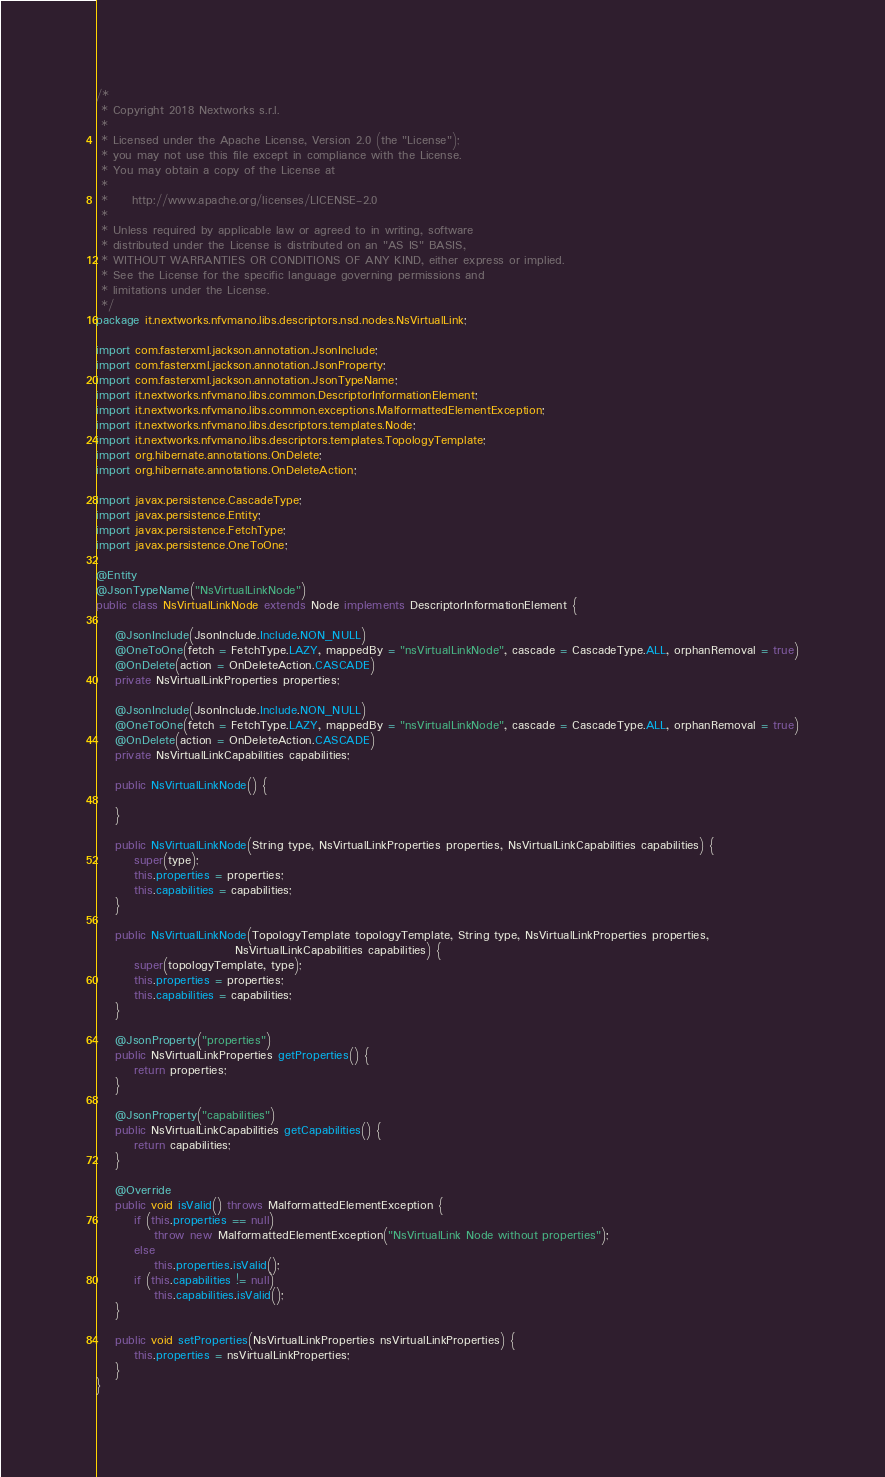<code> <loc_0><loc_0><loc_500><loc_500><_Java_>/*
 * Copyright 2018 Nextworks s.r.l.
 *
 * Licensed under the Apache License, Version 2.0 (the "License");
 * you may not use this file except in compliance with the License.
 * You may obtain a copy of the License at
 *
 *     http://www.apache.org/licenses/LICENSE-2.0
 *
 * Unless required by applicable law or agreed to in writing, software
 * distributed under the License is distributed on an "AS IS" BASIS,
 * WITHOUT WARRANTIES OR CONDITIONS OF ANY KIND, either express or implied.
 * See the License for the specific language governing permissions and
 * limitations under the License.
 */
package it.nextworks.nfvmano.libs.descriptors.nsd.nodes.NsVirtualLink;

import com.fasterxml.jackson.annotation.JsonInclude;
import com.fasterxml.jackson.annotation.JsonProperty;
import com.fasterxml.jackson.annotation.JsonTypeName;
import it.nextworks.nfvmano.libs.common.DescriptorInformationElement;
import it.nextworks.nfvmano.libs.common.exceptions.MalformattedElementException;
import it.nextworks.nfvmano.libs.descriptors.templates.Node;
import it.nextworks.nfvmano.libs.descriptors.templates.TopologyTemplate;
import org.hibernate.annotations.OnDelete;
import org.hibernate.annotations.OnDeleteAction;

import javax.persistence.CascadeType;
import javax.persistence.Entity;
import javax.persistence.FetchType;
import javax.persistence.OneToOne;

@Entity
@JsonTypeName("NsVirtualLinkNode")
public class NsVirtualLinkNode extends Node implements DescriptorInformationElement {

    @JsonInclude(JsonInclude.Include.NON_NULL)
    @OneToOne(fetch = FetchType.LAZY, mappedBy = "nsVirtualLinkNode", cascade = CascadeType.ALL, orphanRemoval = true)
    @OnDelete(action = OnDeleteAction.CASCADE)
    private NsVirtualLinkProperties properties;

    @JsonInclude(JsonInclude.Include.NON_NULL)
    @OneToOne(fetch = FetchType.LAZY, mappedBy = "nsVirtualLinkNode", cascade = CascadeType.ALL, orphanRemoval = true)
    @OnDelete(action = OnDeleteAction.CASCADE)
    private NsVirtualLinkCapabilities capabilities;

    public NsVirtualLinkNode() {

    }

    public NsVirtualLinkNode(String type, NsVirtualLinkProperties properties, NsVirtualLinkCapabilities capabilities) {
        super(type);
        this.properties = properties;
        this.capabilities = capabilities;
    }

    public NsVirtualLinkNode(TopologyTemplate topologyTemplate, String type, NsVirtualLinkProperties properties,
                             NsVirtualLinkCapabilities capabilities) {
        super(topologyTemplate, type);
        this.properties = properties;
        this.capabilities = capabilities;
    }

    @JsonProperty("properties")
    public NsVirtualLinkProperties getProperties() {
        return properties;
    }

    @JsonProperty("capabilities")
    public NsVirtualLinkCapabilities getCapabilities() {
        return capabilities;
    }

    @Override
    public void isValid() throws MalformattedElementException {
        if (this.properties == null)
            throw new MalformattedElementException("NsVirtualLink Node without properties");
        else
            this.properties.isValid();
        if (this.capabilities != null)
            this.capabilities.isValid();
    }

    public void setProperties(NsVirtualLinkProperties nsVirtualLinkProperties) {
        this.properties = nsVirtualLinkProperties;
    }
}
</code> 